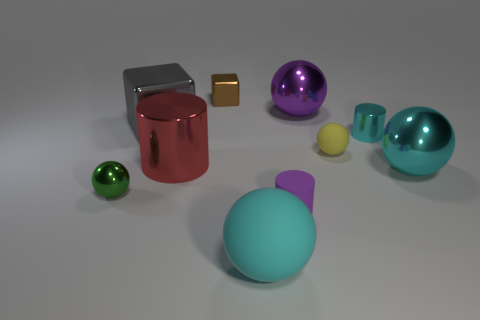Subtract all purple spheres. How many spheres are left? 4 Subtract all yellow matte balls. How many balls are left? 4 Subtract all brown balls. Subtract all blue cubes. How many balls are left? 5 Subtract all blocks. How many objects are left? 8 Add 5 big brown shiny objects. How many big brown shiny objects exist? 5 Subtract 1 purple cylinders. How many objects are left? 9 Subtract all large balls. Subtract all red objects. How many objects are left? 6 Add 1 small yellow matte things. How many small yellow matte things are left? 2 